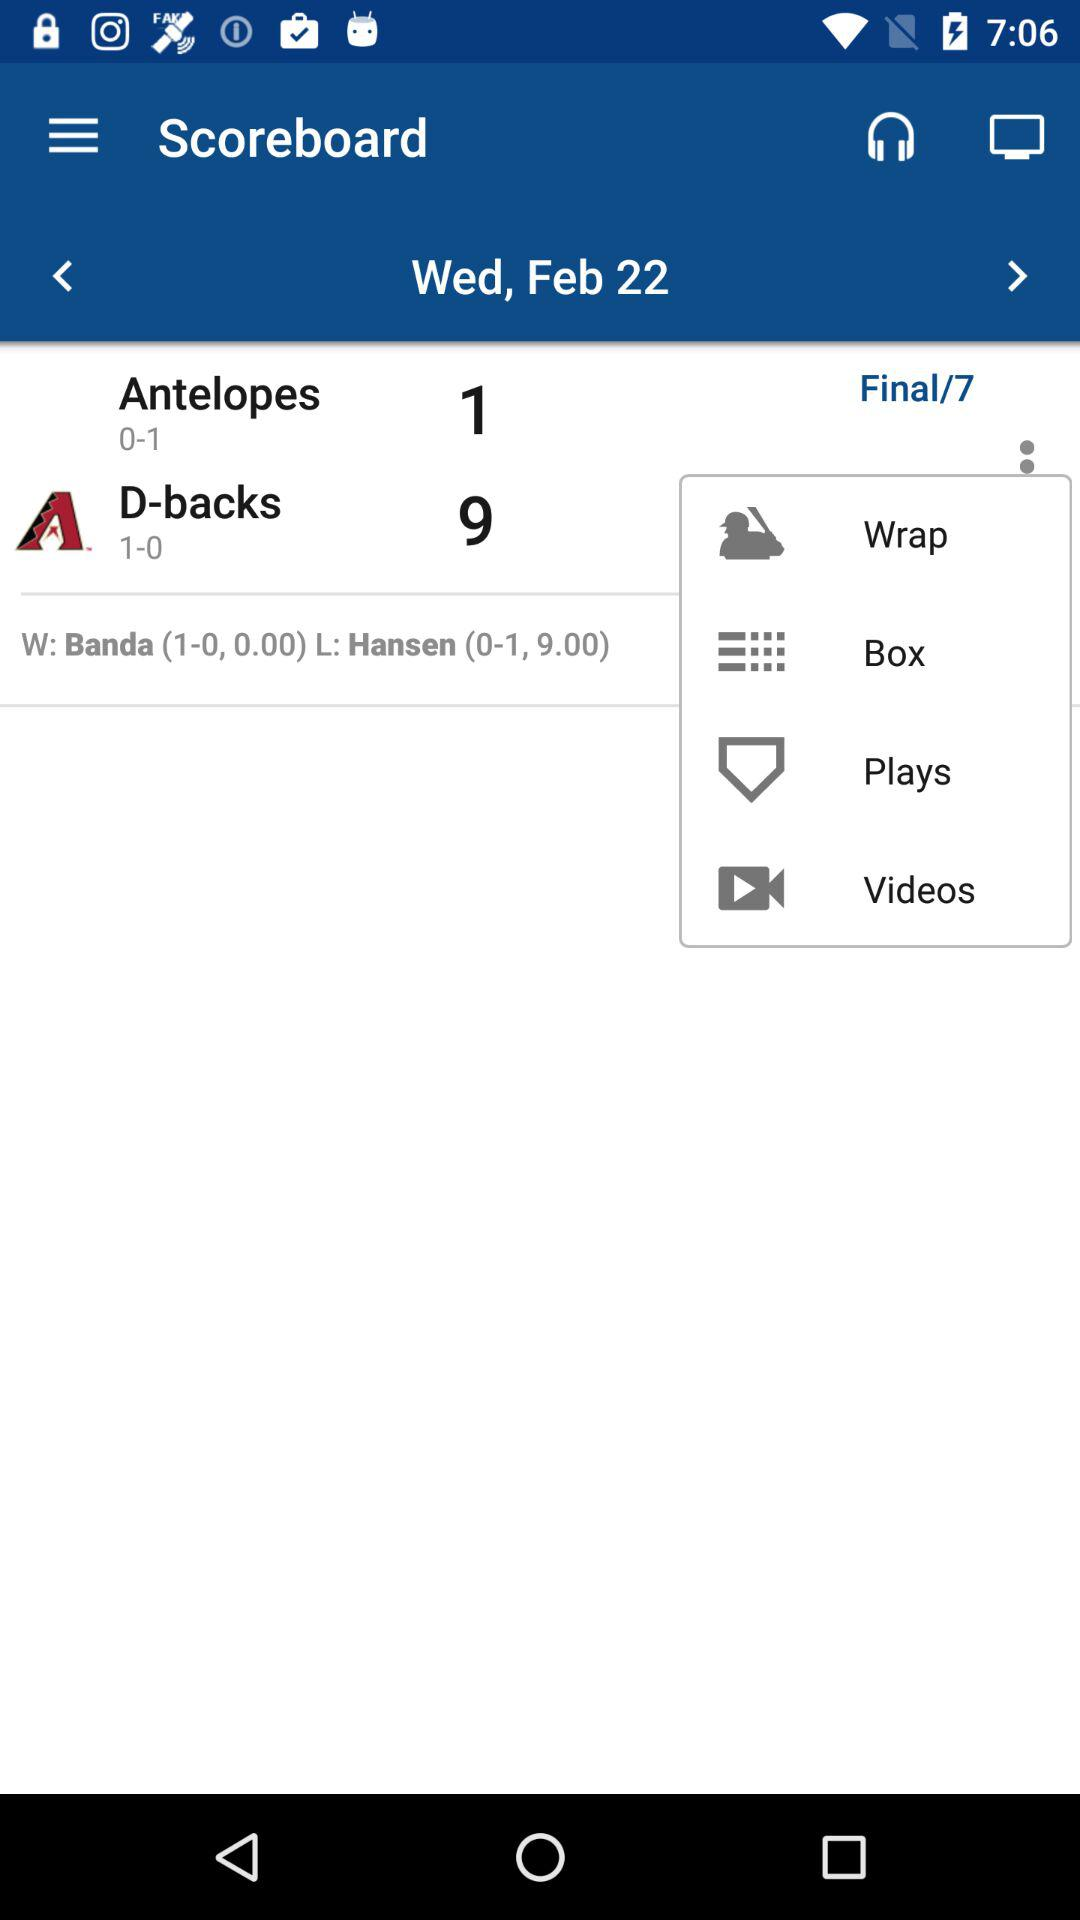How many runs did "D-backs" score? "D-backs" scored 9 runs. 